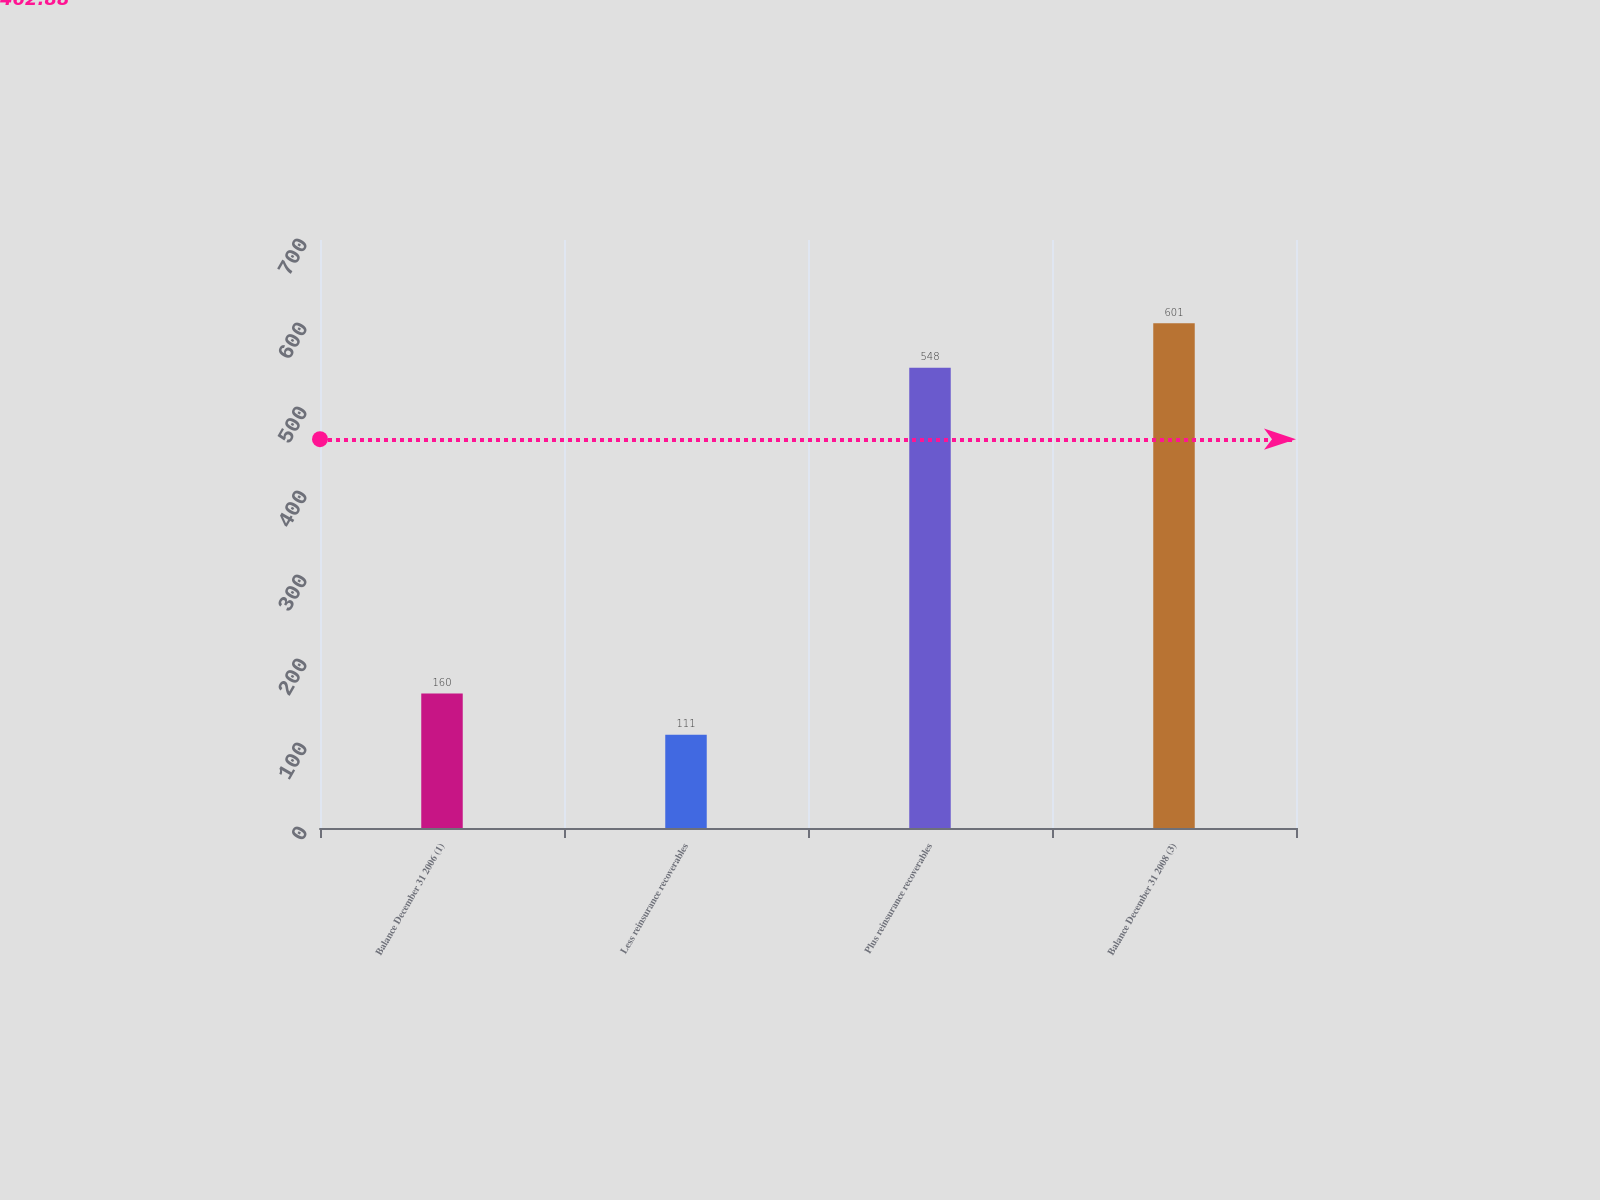<chart> <loc_0><loc_0><loc_500><loc_500><bar_chart><fcel>Balance December 31 2006 (1)<fcel>Less reinsurance recoverables<fcel>Plus reinsurance recoverables<fcel>Balance December 31 2008 (3)<nl><fcel>160<fcel>111<fcel>548<fcel>601<nl></chart> 